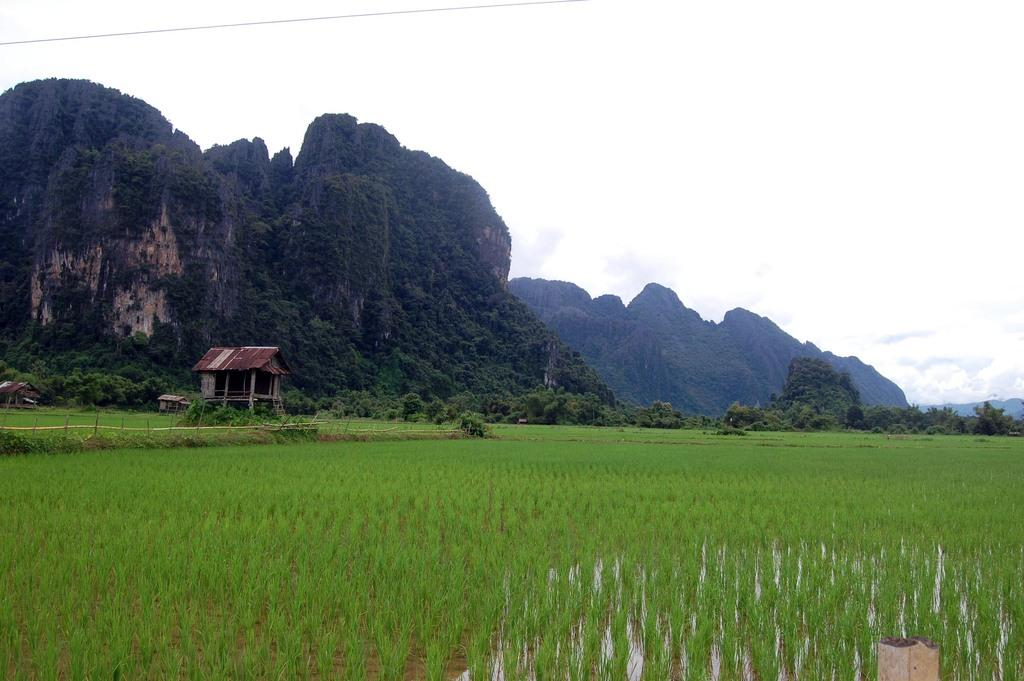What type of structures can be seen in the image? There are small houses in the image. What type of land use is depicted in the image? There is an agricultural field in the image. What type of vegetation is present in the image? There are trees in the image. What type of barrier is present in the image? There is a fence in the image. What type of natural feature is visible in the image? There are mountains covered with trees in the image. What is visible in the sky in the image? There are clouds in the sky in the image. How many legs can be seen on the cushion in the image? There is no cushion present in the image. What type of place is depicted in the image? The image does not depict a specific place; it shows a landscape with small houses, an agricultural field, trees, a fence, mountains, and clouds. 